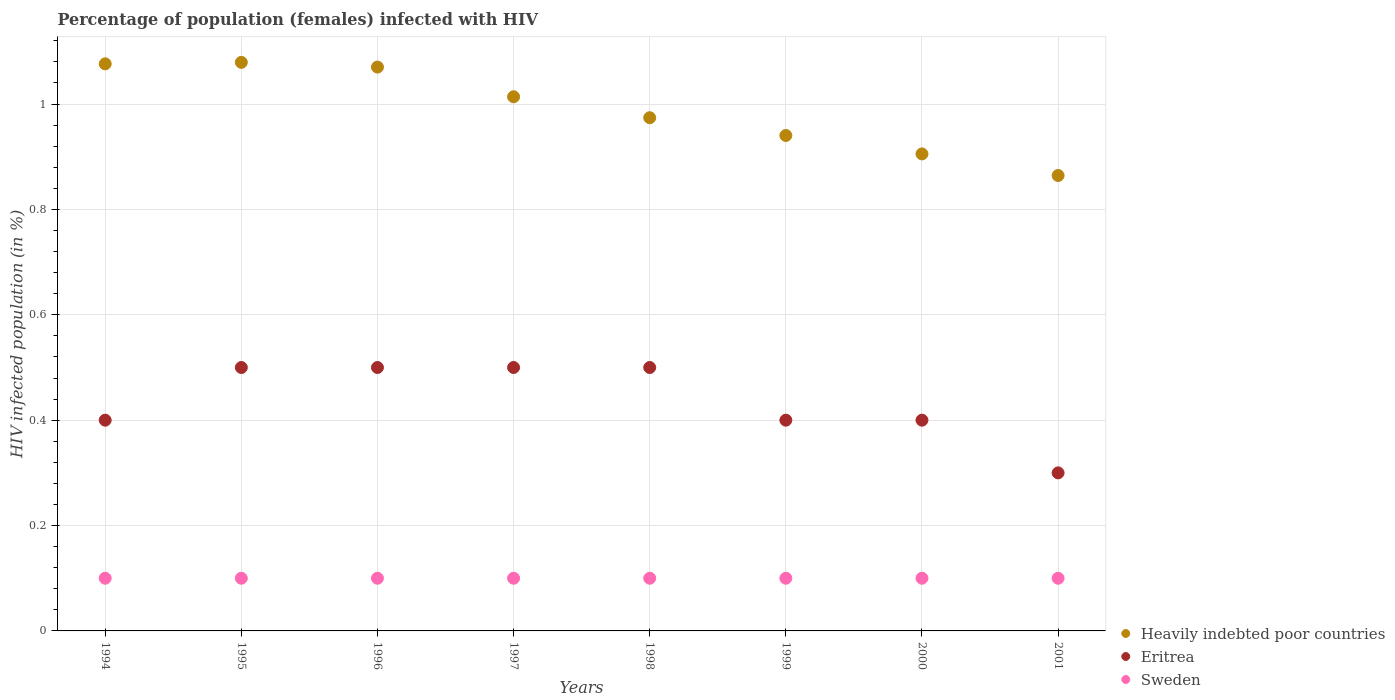Is the number of dotlines equal to the number of legend labels?
Offer a very short reply. Yes. What is the percentage of HIV infected female population in Heavily indebted poor countries in 1998?
Keep it short and to the point. 0.97. Across all years, what is the maximum percentage of HIV infected female population in Sweden?
Ensure brevity in your answer.  0.1. What is the total percentage of HIV infected female population in Sweden in the graph?
Provide a succinct answer. 0.8. What is the difference between the percentage of HIV infected female population in Eritrea in 1995 and that in 2001?
Give a very brief answer. 0.2. What is the difference between the percentage of HIV infected female population in Sweden in 2001 and the percentage of HIV infected female population in Heavily indebted poor countries in 1996?
Your response must be concise. -0.97. What is the average percentage of HIV infected female population in Eritrea per year?
Provide a succinct answer. 0.44. In the year 2001, what is the difference between the percentage of HIV infected female population in Sweden and percentage of HIV infected female population in Eritrea?
Provide a succinct answer. -0.2. What is the ratio of the percentage of HIV infected female population in Heavily indebted poor countries in 1994 to that in 1997?
Offer a very short reply. 1.06. What is the difference between the highest and the second highest percentage of HIV infected female population in Eritrea?
Make the answer very short. 0. What is the difference between the highest and the lowest percentage of HIV infected female population in Sweden?
Keep it short and to the point. 0. In how many years, is the percentage of HIV infected female population in Heavily indebted poor countries greater than the average percentage of HIV infected female population in Heavily indebted poor countries taken over all years?
Offer a very short reply. 4. Does the percentage of HIV infected female population in Sweden monotonically increase over the years?
Offer a terse response. No. Is the percentage of HIV infected female population in Sweden strictly less than the percentage of HIV infected female population in Heavily indebted poor countries over the years?
Your answer should be compact. Yes. How many dotlines are there?
Offer a very short reply. 3. Are the values on the major ticks of Y-axis written in scientific E-notation?
Make the answer very short. No. Where does the legend appear in the graph?
Give a very brief answer. Bottom right. What is the title of the graph?
Make the answer very short. Percentage of population (females) infected with HIV. Does "Other small states" appear as one of the legend labels in the graph?
Give a very brief answer. No. What is the label or title of the X-axis?
Provide a succinct answer. Years. What is the label or title of the Y-axis?
Make the answer very short. HIV infected population (in %). What is the HIV infected population (in %) of Heavily indebted poor countries in 1994?
Your response must be concise. 1.08. What is the HIV infected population (in %) in Heavily indebted poor countries in 1995?
Give a very brief answer. 1.08. What is the HIV infected population (in %) of Heavily indebted poor countries in 1996?
Offer a very short reply. 1.07. What is the HIV infected population (in %) of Sweden in 1996?
Offer a terse response. 0.1. What is the HIV infected population (in %) in Heavily indebted poor countries in 1997?
Make the answer very short. 1.01. What is the HIV infected population (in %) in Sweden in 1997?
Provide a short and direct response. 0.1. What is the HIV infected population (in %) of Heavily indebted poor countries in 1998?
Give a very brief answer. 0.97. What is the HIV infected population (in %) in Heavily indebted poor countries in 1999?
Provide a short and direct response. 0.94. What is the HIV infected population (in %) of Sweden in 1999?
Provide a succinct answer. 0.1. What is the HIV infected population (in %) in Heavily indebted poor countries in 2000?
Your response must be concise. 0.91. What is the HIV infected population (in %) in Heavily indebted poor countries in 2001?
Provide a short and direct response. 0.86. What is the HIV infected population (in %) of Eritrea in 2001?
Your answer should be very brief. 0.3. What is the HIV infected population (in %) of Sweden in 2001?
Make the answer very short. 0.1. Across all years, what is the maximum HIV infected population (in %) of Heavily indebted poor countries?
Your answer should be very brief. 1.08. Across all years, what is the maximum HIV infected population (in %) of Eritrea?
Your response must be concise. 0.5. Across all years, what is the minimum HIV infected population (in %) in Heavily indebted poor countries?
Offer a terse response. 0.86. Across all years, what is the minimum HIV infected population (in %) in Eritrea?
Offer a terse response. 0.3. What is the total HIV infected population (in %) of Heavily indebted poor countries in the graph?
Make the answer very short. 7.92. What is the total HIV infected population (in %) in Eritrea in the graph?
Keep it short and to the point. 3.5. What is the total HIV infected population (in %) in Sweden in the graph?
Your answer should be very brief. 0.8. What is the difference between the HIV infected population (in %) of Heavily indebted poor countries in 1994 and that in 1995?
Your response must be concise. -0. What is the difference between the HIV infected population (in %) in Eritrea in 1994 and that in 1995?
Give a very brief answer. -0.1. What is the difference between the HIV infected population (in %) in Sweden in 1994 and that in 1995?
Give a very brief answer. 0. What is the difference between the HIV infected population (in %) of Heavily indebted poor countries in 1994 and that in 1996?
Provide a short and direct response. 0.01. What is the difference between the HIV infected population (in %) in Sweden in 1994 and that in 1996?
Provide a short and direct response. 0. What is the difference between the HIV infected population (in %) of Heavily indebted poor countries in 1994 and that in 1997?
Your answer should be very brief. 0.06. What is the difference between the HIV infected population (in %) of Eritrea in 1994 and that in 1997?
Your answer should be very brief. -0.1. What is the difference between the HIV infected population (in %) in Heavily indebted poor countries in 1994 and that in 1998?
Keep it short and to the point. 0.1. What is the difference between the HIV infected population (in %) in Eritrea in 1994 and that in 1998?
Make the answer very short. -0.1. What is the difference between the HIV infected population (in %) in Sweden in 1994 and that in 1998?
Provide a succinct answer. 0. What is the difference between the HIV infected population (in %) of Heavily indebted poor countries in 1994 and that in 1999?
Give a very brief answer. 0.14. What is the difference between the HIV infected population (in %) in Eritrea in 1994 and that in 1999?
Make the answer very short. 0. What is the difference between the HIV infected population (in %) in Sweden in 1994 and that in 1999?
Your answer should be very brief. 0. What is the difference between the HIV infected population (in %) of Heavily indebted poor countries in 1994 and that in 2000?
Offer a very short reply. 0.17. What is the difference between the HIV infected population (in %) of Eritrea in 1994 and that in 2000?
Provide a succinct answer. 0. What is the difference between the HIV infected population (in %) in Sweden in 1994 and that in 2000?
Your response must be concise. 0. What is the difference between the HIV infected population (in %) in Heavily indebted poor countries in 1994 and that in 2001?
Provide a short and direct response. 0.21. What is the difference between the HIV infected population (in %) in Sweden in 1994 and that in 2001?
Keep it short and to the point. 0. What is the difference between the HIV infected population (in %) in Heavily indebted poor countries in 1995 and that in 1996?
Provide a succinct answer. 0.01. What is the difference between the HIV infected population (in %) in Eritrea in 1995 and that in 1996?
Your answer should be compact. 0. What is the difference between the HIV infected population (in %) in Sweden in 1995 and that in 1996?
Your answer should be compact. 0. What is the difference between the HIV infected population (in %) of Heavily indebted poor countries in 1995 and that in 1997?
Ensure brevity in your answer.  0.07. What is the difference between the HIV infected population (in %) of Heavily indebted poor countries in 1995 and that in 1998?
Provide a succinct answer. 0.11. What is the difference between the HIV infected population (in %) of Eritrea in 1995 and that in 1998?
Provide a short and direct response. 0. What is the difference between the HIV infected population (in %) of Sweden in 1995 and that in 1998?
Your response must be concise. 0. What is the difference between the HIV infected population (in %) in Heavily indebted poor countries in 1995 and that in 1999?
Your answer should be very brief. 0.14. What is the difference between the HIV infected population (in %) of Sweden in 1995 and that in 1999?
Make the answer very short. 0. What is the difference between the HIV infected population (in %) in Heavily indebted poor countries in 1995 and that in 2000?
Your answer should be very brief. 0.17. What is the difference between the HIV infected population (in %) of Eritrea in 1995 and that in 2000?
Ensure brevity in your answer.  0.1. What is the difference between the HIV infected population (in %) of Sweden in 1995 and that in 2000?
Make the answer very short. 0. What is the difference between the HIV infected population (in %) of Heavily indebted poor countries in 1995 and that in 2001?
Provide a succinct answer. 0.21. What is the difference between the HIV infected population (in %) of Sweden in 1995 and that in 2001?
Make the answer very short. 0. What is the difference between the HIV infected population (in %) of Heavily indebted poor countries in 1996 and that in 1997?
Make the answer very short. 0.06. What is the difference between the HIV infected population (in %) of Sweden in 1996 and that in 1997?
Keep it short and to the point. 0. What is the difference between the HIV infected population (in %) of Heavily indebted poor countries in 1996 and that in 1998?
Provide a short and direct response. 0.1. What is the difference between the HIV infected population (in %) of Eritrea in 1996 and that in 1998?
Offer a terse response. 0. What is the difference between the HIV infected population (in %) in Heavily indebted poor countries in 1996 and that in 1999?
Offer a terse response. 0.13. What is the difference between the HIV infected population (in %) in Heavily indebted poor countries in 1996 and that in 2000?
Provide a succinct answer. 0.16. What is the difference between the HIV infected population (in %) of Heavily indebted poor countries in 1996 and that in 2001?
Ensure brevity in your answer.  0.21. What is the difference between the HIV infected population (in %) in Eritrea in 1996 and that in 2001?
Your answer should be compact. 0.2. What is the difference between the HIV infected population (in %) in Sweden in 1996 and that in 2001?
Your answer should be compact. 0. What is the difference between the HIV infected population (in %) in Heavily indebted poor countries in 1997 and that in 1998?
Keep it short and to the point. 0.04. What is the difference between the HIV infected population (in %) in Heavily indebted poor countries in 1997 and that in 1999?
Give a very brief answer. 0.07. What is the difference between the HIV infected population (in %) in Eritrea in 1997 and that in 1999?
Keep it short and to the point. 0.1. What is the difference between the HIV infected population (in %) of Heavily indebted poor countries in 1997 and that in 2000?
Your answer should be compact. 0.11. What is the difference between the HIV infected population (in %) in Eritrea in 1997 and that in 2000?
Your answer should be compact. 0.1. What is the difference between the HIV infected population (in %) in Sweden in 1997 and that in 2000?
Give a very brief answer. 0. What is the difference between the HIV infected population (in %) of Heavily indebted poor countries in 1997 and that in 2001?
Make the answer very short. 0.15. What is the difference between the HIV infected population (in %) of Eritrea in 1997 and that in 2001?
Keep it short and to the point. 0.2. What is the difference between the HIV infected population (in %) in Heavily indebted poor countries in 1998 and that in 1999?
Provide a succinct answer. 0.03. What is the difference between the HIV infected population (in %) in Eritrea in 1998 and that in 1999?
Your response must be concise. 0.1. What is the difference between the HIV infected population (in %) of Heavily indebted poor countries in 1998 and that in 2000?
Offer a very short reply. 0.07. What is the difference between the HIV infected population (in %) of Heavily indebted poor countries in 1998 and that in 2001?
Make the answer very short. 0.11. What is the difference between the HIV infected population (in %) of Eritrea in 1998 and that in 2001?
Keep it short and to the point. 0.2. What is the difference between the HIV infected population (in %) in Sweden in 1998 and that in 2001?
Ensure brevity in your answer.  0. What is the difference between the HIV infected population (in %) in Heavily indebted poor countries in 1999 and that in 2000?
Make the answer very short. 0.03. What is the difference between the HIV infected population (in %) in Eritrea in 1999 and that in 2000?
Provide a succinct answer. 0. What is the difference between the HIV infected population (in %) of Sweden in 1999 and that in 2000?
Keep it short and to the point. 0. What is the difference between the HIV infected population (in %) of Heavily indebted poor countries in 1999 and that in 2001?
Your answer should be very brief. 0.08. What is the difference between the HIV infected population (in %) in Eritrea in 1999 and that in 2001?
Give a very brief answer. 0.1. What is the difference between the HIV infected population (in %) in Sweden in 1999 and that in 2001?
Ensure brevity in your answer.  0. What is the difference between the HIV infected population (in %) of Heavily indebted poor countries in 2000 and that in 2001?
Offer a terse response. 0.04. What is the difference between the HIV infected population (in %) of Heavily indebted poor countries in 1994 and the HIV infected population (in %) of Eritrea in 1995?
Offer a very short reply. 0.58. What is the difference between the HIV infected population (in %) in Heavily indebted poor countries in 1994 and the HIV infected population (in %) in Sweden in 1995?
Ensure brevity in your answer.  0.98. What is the difference between the HIV infected population (in %) of Heavily indebted poor countries in 1994 and the HIV infected population (in %) of Eritrea in 1996?
Your answer should be very brief. 0.58. What is the difference between the HIV infected population (in %) in Heavily indebted poor countries in 1994 and the HIV infected population (in %) in Sweden in 1996?
Give a very brief answer. 0.98. What is the difference between the HIV infected population (in %) in Eritrea in 1994 and the HIV infected population (in %) in Sweden in 1996?
Offer a very short reply. 0.3. What is the difference between the HIV infected population (in %) in Heavily indebted poor countries in 1994 and the HIV infected population (in %) in Eritrea in 1997?
Offer a very short reply. 0.58. What is the difference between the HIV infected population (in %) of Heavily indebted poor countries in 1994 and the HIV infected population (in %) of Sweden in 1997?
Provide a succinct answer. 0.98. What is the difference between the HIV infected population (in %) in Heavily indebted poor countries in 1994 and the HIV infected population (in %) in Eritrea in 1998?
Keep it short and to the point. 0.58. What is the difference between the HIV infected population (in %) of Heavily indebted poor countries in 1994 and the HIV infected population (in %) of Sweden in 1998?
Offer a very short reply. 0.98. What is the difference between the HIV infected population (in %) in Eritrea in 1994 and the HIV infected population (in %) in Sweden in 1998?
Offer a very short reply. 0.3. What is the difference between the HIV infected population (in %) in Heavily indebted poor countries in 1994 and the HIV infected population (in %) in Eritrea in 1999?
Offer a terse response. 0.68. What is the difference between the HIV infected population (in %) of Heavily indebted poor countries in 1994 and the HIV infected population (in %) of Sweden in 1999?
Make the answer very short. 0.98. What is the difference between the HIV infected population (in %) in Heavily indebted poor countries in 1994 and the HIV infected population (in %) in Eritrea in 2000?
Your answer should be compact. 0.68. What is the difference between the HIV infected population (in %) of Heavily indebted poor countries in 1994 and the HIV infected population (in %) of Sweden in 2000?
Keep it short and to the point. 0.98. What is the difference between the HIV infected population (in %) of Eritrea in 1994 and the HIV infected population (in %) of Sweden in 2000?
Provide a short and direct response. 0.3. What is the difference between the HIV infected population (in %) of Heavily indebted poor countries in 1994 and the HIV infected population (in %) of Eritrea in 2001?
Your answer should be compact. 0.78. What is the difference between the HIV infected population (in %) in Heavily indebted poor countries in 1994 and the HIV infected population (in %) in Sweden in 2001?
Ensure brevity in your answer.  0.98. What is the difference between the HIV infected population (in %) in Eritrea in 1994 and the HIV infected population (in %) in Sweden in 2001?
Provide a succinct answer. 0.3. What is the difference between the HIV infected population (in %) of Heavily indebted poor countries in 1995 and the HIV infected population (in %) of Eritrea in 1996?
Keep it short and to the point. 0.58. What is the difference between the HIV infected population (in %) of Heavily indebted poor countries in 1995 and the HIV infected population (in %) of Sweden in 1996?
Your response must be concise. 0.98. What is the difference between the HIV infected population (in %) of Heavily indebted poor countries in 1995 and the HIV infected population (in %) of Eritrea in 1997?
Provide a succinct answer. 0.58. What is the difference between the HIV infected population (in %) of Heavily indebted poor countries in 1995 and the HIV infected population (in %) of Sweden in 1997?
Offer a very short reply. 0.98. What is the difference between the HIV infected population (in %) of Eritrea in 1995 and the HIV infected population (in %) of Sweden in 1997?
Give a very brief answer. 0.4. What is the difference between the HIV infected population (in %) in Heavily indebted poor countries in 1995 and the HIV infected population (in %) in Eritrea in 1998?
Your answer should be compact. 0.58. What is the difference between the HIV infected population (in %) in Heavily indebted poor countries in 1995 and the HIV infected population (in %) in Sweden in 1998?
Provide a short and direct response. 0.98. What is the difference between the HIV infected population (in %) in Heavily indebted poor countries in 1995 and the HIV infected population (in %) in Eritrea in 1999?
Offer a terse response. 0.68. What is the difference between the HIV infected population (in %) in Heavily indebted poor countries in 1995 and the HIV infected population (in %) in Sweden in 1999?
Give a very brief answer. 0.98. What is the difference between the HIV infected population (in %) of Heavily indebted poor countries in 1995 and the HIV infected population (in %) of Eritrea in 2000?
Ensure brevity in your answer.  0.68. What is the difference between the HIV infected population (in %) in Heavily indebted poor countries in 1995 and the HIV infected population (in %) in Sweden in 2000?
Keep it short and to the point. 0.98. What is the difference between the HIV infected population (in %) of Heavily indebted poor countries in 1995 and the HIV infected population (in %) of Eritrea in 2001?
Offer a very short reply. 0.78. What is the difference between the HIV infected population (in %) in Heavily indebted poor countries in 1995 and the HIV infected population (in %) in Sweden in 2001?
Provide a short and direct response. 0.98. What is the difference between the HIV infected population (in %) in Heavily indebted poor countries in 1996 and the HIV infected population (in %) in Eritrea in 1997?
Make the answer very short. 0.57. What is the difference between the HIV infected population (in %) in Heavily indebted poor countries in 1996 and the HIV infected population (in %) in Sweden in 1997?
Keep it short and to the point. 0.97. What is the difference between the HIV infected population (in %) of Heavily indebted poor countries in 1996 and the HIV infected population (in %) of Eritrea in 1998?
Provide a succinct answer. 0.57. What is the difference between the HIV infected population (in %) in Heavily indebted poor countries in 1996 and the HIV infected population (in %) in Sweden in 1998?
Provide a short and direct response. 0.97. What is the difference between the HIV infected population (in %) in Eritrea in 1996 and the HIV infected population (in %) in Sweden in 1998?
Make the answer very short. 0.4. What is the difference between the HIV infected population (in %) of Heavily indebted poor countries in 1996 and the HIV infected population (in %) of Eritrea in 1999?
Offer a very short reply. 0.67. What is the difference between the HIV infected population (in %) in Heavily indebted poor countries in 1996 and the HIV infected population (in %) in Sweden in 1999?
Ensure brevity in your answer.  0.97. What is the difference between the HIV infected population (in %) of Heavily indebted poor countries in 1996 and the HIV infected population (in %) of Eritrea in 2000?
Ensure brevity in your answer.  0.67. What is the difference between the HIV infected population (in %) in Heavily indebted poor countries in 1996 and the HIV infected population (in %) in Sweden in 2000?
Provide a succinct answer. 0.97. What is the difference between the HIV infected population (in %) in Heavily indebted poor countries in 1996 and the HIV infected population (in %) in Eritrea in 2001?
Make the answer very short. 0.77. What is the difference between the HIV infected population (in %) in Heavily indebted poor countries in 1996 and the HIV infected population (in %) in Sweden in 2001?
Ensure brevity in your answer.  0.97. What is the difference between the HIV infected population (in %) of Heavily indebted poor countries in 1997 and the HIV infected population (in %) of Eritrea in 1998?
Keep it short and to the point. 0.51. What is the difference between the HIV infected population (in %) in Heavily indebted poor countries in 1997 and the HIV infected population (in %) in Sweden in 1998?
Provide a succinct answer. 0.91. What is the difference between the HIV infected population (in %) of Eritrea in 1997 and the HIV infected population (in %) of Sweden in 1998?
Provide a short and direct response. 0.4. What is the difference between the HIV infected population (in %) of Heavily indebted poor countries in 1997 and the HIV infected population (in %) of Eritrea in 1999?
Your response must be concise. 0.61. What is the difference between the HIV infected population (in %) of Heavily indebted poor countries in 1997 and the HIV infected population (in %) of Sweden in 1999?
Make the answer very short. 0.91. What is the difference between the HIV infected population (in %) of Eritrea in 1997 and the HIV infected population (in %) of Sweden in 1999?
Provide a succinct answer. 0.4. What is the difference between the HIV infected population (in %) in Heavily indebted poor countries in 1997 and the HIV infected population (in %) in Eritrea in 2000?
Provide a short and direct response. 0.61. What is the difference between the HIV infected population (in %) in Heavily indebted poor countries in 1997 and the HIV infected population (in %) in Sweden in 2000?
Your answer should be very brief. 0.91. What is the difference between the HIV infected population (in %) in Eritrea in 1997 and the HIV infected population (in %) in Sweden in 2000?
Offer a terse response. 0.4. What is the difference between the HIV infected population (in %) of Heavily indebted poor countries in 1997 and the HIV infected population (in %) of Eritrea in 2001?
Make the answer very short. 0.71. What is the difference between the HIV infected population (in %) of Heavily indebted poor countries in 1997 and the HIV infected population (in %) of Sweden in 2001?
Keep it short and to the point. 0.91. What is the difference between the HIV infected population (in %) of Eritrea in 1997 and the HIV infected population (in %) of Sweden in 2001?
Your response must be concise. 0.4. What is the difference between the HIV infected population (in %) in Heavily indebted poor countries in 1998 and the HIV infected population (in %) in Eritrea in 1999?
Ensure brevity in your answer.  0.57. What is the difference between the HIV infected population (in %) in Heavily indebted poor countries in 1998 and the HIV infected population (in %) in Sweden in 1999?
Make the answer very short. 0.87. What is the difference between the HIV infected population (in %) in Eritrea in 1998 and the HIV infected population (in %) in Sweden in 1999?
Offer a terse response. 0.4. What is the difference between the HIV infected population (in %) in Heavily indebted poor countries in 1998 and the HIV infected population (in %) in Eritrea in 2000?
Your response must be concise. 0.57. What is the difference between the HIV infected population (in %) in Heavily indebted poor countries in 1998 and the HIV infected population (in %) in Sweden in 2000?
Provide a short and direct response. 0.87. What is the difference between the HIV infected population (in %) of Eritrea in 1998 and the HIV infected population (in %) of Sweden in 2000?
Keep it short and to the point. 0.4. What is the difference between the HIV infected population (in %) in Heavily indebted poor countries in 1998 and the HIV infected population (in %) in Eritrea in 2001?
Ensure brevity in your answer.  0.67. What is the difference between the HIV infected population (in %) of Heavily indebted poor countries in 1998 and the HIV infected population (in %) of Sweden in 2001?
Give a very brief answer. 0.87. What is the difference between the HIV infected population (in %) in Heavily indebted poor countries in 1999 and the HIV infected population (in %) in Eritrea in 2000?
Provide a succinct answer. 0.54. What is the difference between the HIV infected population (in %) in Heavily indebted poor countries in 1999 and the HIV infected population (in %) in Sweden in 2000?
Your answer should be very brief. 0.84. What is the difference between the HIV infected population (in %) in Eritrea in 1999 and the HIV infected population (in %) in Sweden in 2000?
Offer a very short reply. 0.3. What is the difference between the HIV infected population (in %) in Heavily indebted poor countries in 1999 and the HIV infected population (in %) in Eritrea in 2001?
Ensure brevity in your answer.  0.64. What is the difference between the HIV infected population (in %) of Heavily indebted poor countries in 1999 and the HIV infected population (in %) of Sweden in 2001?
Offer a very short reply. 0.84. What is the difference between the HIV infected population (in %) in Heavily indebted poor countries in 2000 and the HIV infected population (in %) in Eritrea in 2001?
Give a very brief answer. 0.61. What is the difference between the HIV infected population (in %) in Heavily indebted poor countries in 2000 and the HIV infected population (in %) in Sweden in 2001?
Provide a succinct answer. 0.81. What is the difference between the HIV infected population (in %) in Eritrea in 2000 and the HIV infected population (in %) in Sweden in 2001?
Offer a terse response. 0.3. What is the average HIV infected population (in %) in Eritrea per year?
Offer a terse response. 0.44. In the year 1994, what is the difference between the HIV infected population (in %) of Heavily indebted poor countries and HIV infected population (in %) of Eritrea?
Ensure brevity in your answer.  0.68. In the year 1994, what is the difference between the HIV infected population (in %) in Heavily indebted poor countries and HIV infected population (in %) in Sweden?
Your answer should be compact. 0.98. In the year 1994, what is the difference between the HIV infected population (in %) in Eritrea and HIV infected population (in %) in Sweden?
Your answer should be compact. 0.3. In the year 1995, what is the difference between the HIV infected population (in %) in Heavily indebted poor countries and HIV infected population (in %) in Eritrea?
Offer a very short reply. 0.58. In the year 1995, what is the difference between the HIV infected population (in %) in Heavily indebted poor countries and HIV infected population (in %) in Sweden?
Offer a very short reply. 0.98. In the year 1996, what is the difference between the HIV infected population (in %) of Heavily indebted poor countries and HIV infected population (in %) of Eritrea?
Provide a short and direct response. 0.57. In the year 1996, what is the difference between the HIV infected population (in %) of Heavily indebted poor countries and HIV infected population (in %) of Sweden?
Your answer should be very brief. 0.97. In the year 1997, what is the difference between the HIV infected population (in %) in Heavily indebted poor countries and HIV infected population (in %) in Eritrea?
Make the answer very short. 0.51. In the year 1997, what is the difference between the HIV infected population (in %) in Heavily indebted poor countries and HIV infected population (in %) in Sweden?
Give a very brief answer. 0.91. In the year 1998, what is the difference between the HIV infected population (in %) of Heavily indebted poor countries and HIV infected population (in %) of Eritrea?
Your answer should be compact. 0.47. In the year 1998, what is the difference between the HIV infected population (in %) of Heavily indebted poor countries and HIV infected population (in %) of Sweden?
Ensure brevity in your answer.  0.87. In the year 1999, what is the difference between the HIV infected population (in %) in Heavily indebted poor countries and HIV infected population (in %) in Eritrea?
Your response must be concise. 0.54. In the year 1999, what is the difference between the HIV infected population (in %) of Heavily indebted poor countries and HIV infected population (in %) of Sweden?
Provide a short and direct response. 0.84. In the year 1999, what is the difference between the HIV infected population (in %) in Eritrea and HIV infected population (in %) in Sweden?
Offer a terse response. 0.3. In the year 2000, what is the difference between the HIV infected population (in %) of Heavily indebted poor countries and HIV infected population (in %) of Eritrea?
Ensure brevity in your answer.  0.51. In the year 2000, what is the difference between the HIV infected population (in %) in Heavily indebted poor countries and HIV infected population (in %) in Sweden?
Keep it short and to the point. 0.81. In the year 2000, what is the difference between the HIV infected population (in %) of Eritrea and HIV infected population (in %) of Sweden?
Make the answer very short. 0.3. In the year 2001, what is the difference between the HIV infected population (in %) in Heavily indebted poor countries and HIV infected population (in %) in Eritrea?
Offer a terse response. 0.56. In the year 2001, what is the difference between the HIV infected population (in %) of Heavily indebted poor countries and HIV infected population (in %) of Sweden?
Your answer should be very brief. 0.76. What is the ratio of the HIV infected population (in %) of Heavily indebted poor countries in 1994 to that in 1995?
Ensure brevity in your answer.  1. What is the ratio of the HIV infected population (in %) of Sweden in 1994 to that in 1995?
Your response must be concise. 1. What is the ratio of the HIV infected population (in %) in Sweden in 1994 to that in 1996?
Your answer should be compact. 1. What is the ratio of the HIV infected population (in %) of Heavily indebted poor countries in 1994 to that in 1997?
Give a very brief answer. 1.06. What is the ratio of the HIV infected population (in %) of Sweden in 1994 to that in 1997?
Give a very brief answer. 1. What is the ratio of the HIV infected population (in %) of Heavily indebted poor countries in 1994 to that in 1998?
Offer a very short reply. 1.1. What is the ratio of the HIV infected population (in %) of Eritrea in 1994 to that in 1998?
Provide a succinct answer. 0.8. What is the ratio of the HIV infected population (in %) in Heavily indebted poor countries in 1994 to that in 1999?
Provide a short and direct response. 1.14. What is the ratio of the HIV infected population (in %) in Sweden in 1994 to that in 1999?
Offer a terse response. 1. What is the ratio of the HIV infected population (in %) in Heavily indebted poor countries in 1994 to that in 2000?
Provide a succinct answer. 1.19. What is the ratio of the HIV infected population (in %) of Sweden in 1994 to that in 2000?
Provide a succinct answer. 1. What is the ratio of the HIV infected population (in %) in Heavily indebted poor countries in 1994 to that in 2001?
Ensure brevity in your answer.  1.25. What is the ratio of the HIV infected population (in %) in Eritrea in 1994 to that in 2001?
Provide a short and direct response. 1.33. What is the ratio of the HIV infected population (in %) of Heavily indebted poor countries in 1995 to that in 1996?
Give a very brief answer. 1.01. What is the ratio of the HIV infected population (in %) of Eritrea in 1995 to that in 1996?
Offer a terse response. 1. What is the ratio of the HIV infected population (in %) of Sweden in 1995 to that in 1996?
Provide a succinct answer. 1. What is the ratio of the HIV infected population (in %) in Heavily indebted poor countries in 1995 to that in 1997?
Your answer should be very brief. 1.06. What is the ratio of the HIV infected population (in %) of Eritrea in 1995 to that in 1997?
Your answer should be compact. 1. What is the ratio of the HIV infected population (in %) in Sweden in 1995 to that in 1997?
Make the answer very short. 1. What is the ratio of the HIV infected population (in %) of Heavily indebted poor countries in 1995 to that in 1998?
Offer a very short reply. 1.11. What is the ratio of the HIV infected population (in %) in Sweden in 1995 to that in 1998?
Offer a very short reply. 1. What is the ratio of the HIV infected population (in %) of Heavily indebted poor countries in 1995 to that in 1999?
Provide a short and direct response. 1.15. What is the ratio of the HIV infected population (in %) of Sweden in 1995 to that in 1999?
Offer a terse response. 1. What is the ratio of the HIV infected population (in %) in Heavily indebted poor countries in 1995 to that in 2000?
Your answer should be very brief. 1.19. What is the ratio of the HIV infected population (in %) of Eritrea in 1995 to that in 2000?
Your response must be concise. 1.25. What is the ratio of the HIV infected population (in %) in Heavily indebted poor countries in 1995 to that in 2001?
Provide a succinct answer. 1.25. What is the ratio of the HIV infected population (in %) in Heavily indebted poor countries in 1996 to that in 1997?
Your answer should be very brief. 1.06. What is the ratio of the HIV infected population (in %) of Eritrea in 1996 to that in 1997?
Provide a short and direct response. 1. What is the ratio of the HIV infected population (in %) of Heavily indebted poor countries in 1996 to that in 1998?
Offer a very short reply. 1.1. What is the ratio of the HIV infected population (in %) of Eritrea in 1996 to that in 1998?
Keep it short and to the point. 1. What is the ratio of the HIV infected population (in %) in Heavily indebted poor countries in 1996 to that in 1999?
Provide a succinct answer. 1.14. What is the ratio of the HIV infected population (in %) of Sweden in 1996 to that in 1999?
Your answer should be very brief. 1. What is the ratio of the HIV infected population (in %) of Heavily indebted poor countries in 1996 to that in 2000?
Ensure brevity in your answer.  1.18. What is the ratio of the HIV infected population (in %) of Heavily indebted poor countries in 1996 to that in 2001?
Your response must be concise. 1.24. What is the ratio of the HIV infected population (in %) in Heavily indebted poor countries in 1997 to that in 1998?
Ensure brevity in your answer.  1.04. What is the ratio of the HIV infected population (in %) in Heavily indebted poor countries in 1997 to that in 1999?
Your answer should be very brief. 1.08. What is the ratio of the HIV infected population (in %) of Eritrea in 1997 to that in 1999?
Ensure brevity in your answer.  1.25. What is the ratio of the HIV infected population (in %) in Sweden in 1997 to that in 1999?
Provide a succinct answer. 1. What is the ratio of the HIV infected population (in %) in Heavily indebted poor countries in 1997 to that in 2000?
Provide a succinct answer. 1.12. What is the ratio of the HIV infected population (in %) of Heavily indebted poor countries in 1997 to that in 2001?
Provide a short and direct response. 1.17. What is the ratio of the HIV infected population (in %) of Eritrea in 1997 to that in 2001?
Offer a terse response. 1.67. What is the ratio of the HIV infected population (in %) of Heavily indebted poor countries in 1998 to that in 1999?
Your answer should be compact. 1.04. What is the ratio of the HIV infected population (in %) of Heavily indebted poor countries in 1998 to that in 2000?
Make the answer very short. 1.08. What is the ratio of the HIV infected population (in %) of Eritrea in 1998 to that in 2000?
Offer a very short reply. 1.25. What is the ratio of the HIV infected population (in %) in Sweden in 1998 to that in 2000?
Offer a terse response. 1. What is the ratio of the HIV infected population (in %) of Heavily indebted poor countries in 1998 to that in 2001?
Keep it short and to the point. 1.13. What is the ratio of the HIV infected population (in %) in Sweden in 1998 to that in 2001?
Provide a succinct answer. 1. What is the ratio of the HIV infected population (in %) of Heavily indebted poor countries in 1999 to that in 2000?
Your answer should be very brief. 1.04. What is the ratio of the HIV infected population (in %) of Sweden in 1999 to that in 2000?
Your answer should be very brief. 1. What is the ratio of the HIV infected population (in %) in Heavily indebted poor countries in 1999 to that in 2001?
Your response must be concise. 1.09. What is the ratio of the HIV infected population (in %) of Eritrea in 1999 to that in 2001?
Ensure brevity in your answer.  1.33. What is the ratio of the HIV infected population (in %) of Sweden in 1999 to that in 2001?
Provide a short and direct response. 1. What is the ratio of the HIV infected population (in %) of Heavily indebted poor countries in 2000 to that in 2001?
Your response must be concise. 1.05. What is the ratio of the HIV infected population (in %) in Eritrea in 2000 to that in 2001?
Make the answer very short. 1.33. What is the ratio of the HIV infected population (in %) in Sweden in 2000 to that in 2001?
Your answer should be compact. 1. What is the difference between the highest and the second highest HIV infected population (in %) of Heavily indebted poor countries?
Offer a terse response. 0. What is the difference between the highest and the second highest HIV infected population (in %) in Sweden?
Ensure brevity in your answer.  0. What is the difference between the highest and the lowest HIV infected population (in %) in Heavily indebted poor countries?
Provide a succinct answer. 0.21. What is the difference between the highest and the lowest HIV infected population (in %) in Eritrea?
Make the answer very short. 0.2. 